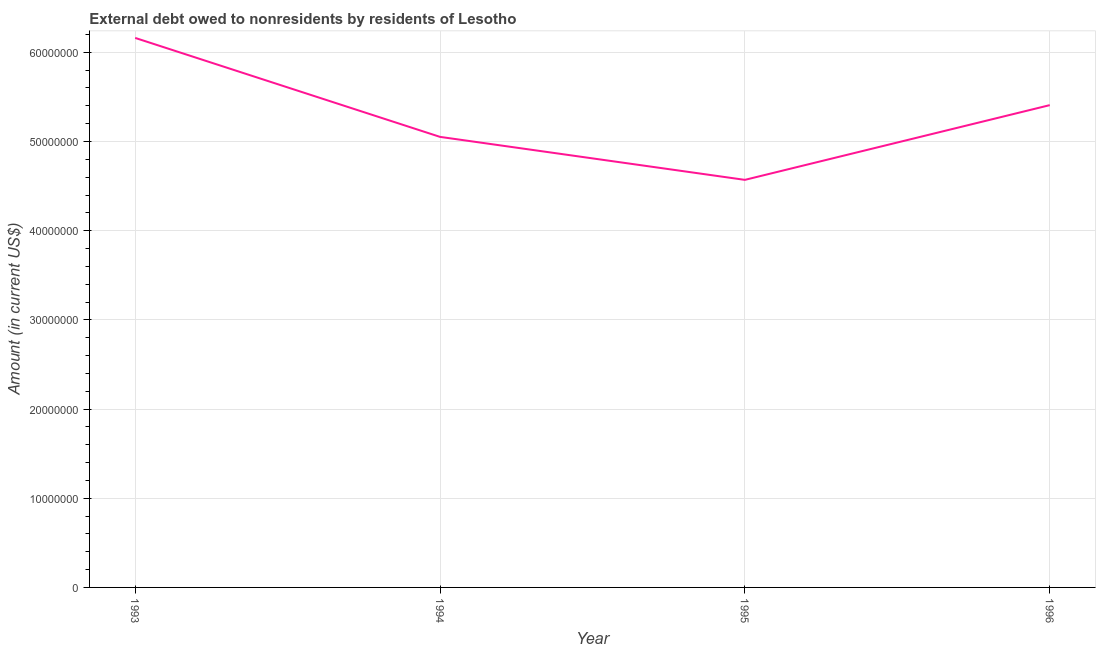What is the debt in 1996?
Provide a succinct answer. 5.41e+07. Across all years, what is the maximum debt?
Ensure brevity in your answer.  6.16e+07. Across all years, what is the minimum debt?
Provide a short and direct response. 4.57e+07. In which year was the debt maximum?
Provide a succinct answer. 1993. What is the sum of the debt?
Ensure brevity in your answer.  2.12e+08. What is the difference between the debt in 1993 and 1995?
Provide a succinct answer. 1.59e+07. What is the average debt per year?
Your answer should be compact. 5.30e+07. What is the median debt?
Give a very brief answer. 5.23e+07. In how many years, is the debt greater than 8000000 US$?
Give a very brief answer. 4. What is the ratio of the debt in 1993 to that in 1995?
Provide a short and direct response. 1.35. Is the debt in 1995 less than that in 1996?
Offer a terse response. Yes. Is the difference between the debt in 1995 and 1996 greater than the difference between any two years?
Provide a succinct answer. No. What is the difference between the highest and the second highest debt?
Your answer should be very brief. 7.54e+06. What is the difference between the highest and the lowest debt?
Ensure brevity in your answer.  1.59e+07. In how many years, is the debt greater than the average debt taken over all years?
Your answer should be very brief. 2. Does the debt monotonically increase over the years?
Offer a very short reply. No. How many lines are there?
Provide a succinct answer. 1. How many years are there in the graph?
Your answer should be very brief. 4. What is the difference between two consecutive major ticks on the Y-axis?
Provide a succinct answer. 1.00e+07. Are the values on the major ticks of Y-axis written in scientific E-notation?
Make the answer very short. No. Does the graph contain any zero values?
Offer a very short reply. No. Does the graph contain grids?
Keep it short and to the point. Yes. What is the title of the graph?
Offer a terse response. External debt owed to nonresidents by residents of Lesotho. What is the label or title of the Y-axis?
Provide a short and direct response. Amount (in current US$). What is the Amount (in current US$) of 1993?
Your answer should be very brief. 6.16e+07. What is the Amount (in current US$) of 1994?
Your answer should be very brief. 5.05e+07. What is the Amount (in current US$) in 1995?
Provide a short and direct response. 4.57e+07. What is the Amount (in current US$) in 1996?
Offer a very short reply. 5.41e+07. What is the difference between the Amount (in current US$) in 1993 and 1994?
Give a very brief answer. 1.11e+07. What is the difference between the Amount (in current US$) in 1993 and 1995?
Keep it short and to the point. 1.59e+07. What is the difference between the Amount (in current US$) in 1993 and 1996?
Offer a very short reply. 7.54e+06. What is the difference between the Amount (in current US$) in 1994 and 1995?
Your answer should be very brief. 4.82e+06. What is the difference between the Amount (in current US$) in 1994 and 1996?
Offer a very short reply. -3.56e+06. What is the difference between the Amount (in current US$) in 1995 and 1996?
Your response must be concise. -8.38e+06. What is the ratio of the Amount (in current US$) in 1993 to that in 1994?
Your answer should be very brief. 1.22. What is the ratio of the Amount (in current US$) in 1993 to that in 1995?
Provide a succinct answer. 1.35. What is the ratio of the Amount (in current US$) in 1993 to that in 1996?
Your answer should be compact. 1.14. What is the ratio of the Amount (in current US$) in 1994 to that in 1995?
Keep it short and to the point. 1.1. What is the ratio of the Amount (in current US$) in 1994 to that in 1996?
Keep it short and to the point. 0.93. What is the ratio of the Amount (in current US$) in 1995 to that in 1996?
Ensure brevity in your answer.  0.84. 